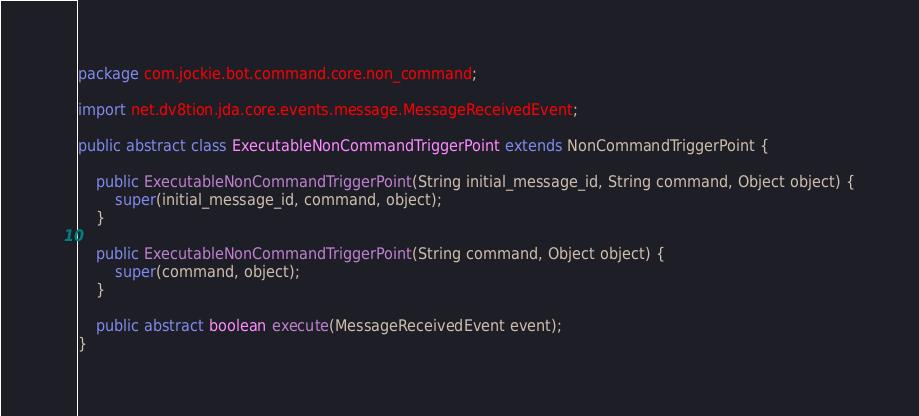Convert code to text. <code><loc_0><loc_0><loc_500><loc_500><_Java_>package com.jockie.bot.command.core.non_command;

import net.dv8tion.jda.core.events.message.MessageReceivedEvent;

public abstract class ExecutableNonCommandTriggerPoint extends NonCommandTriggerPoint {
	
	public ExecutableNonCommandTriggerPoint(String initial_message_id, String command, Object object) {
		super(initial_message_id, command, object);
	}
	
	public ExecutableNonCommandTriggerPoint(String command, Object object) {
		super(command, object);
	}
	
	public abstract boolean execute(MessageReceivedEvent event);
}</code> 